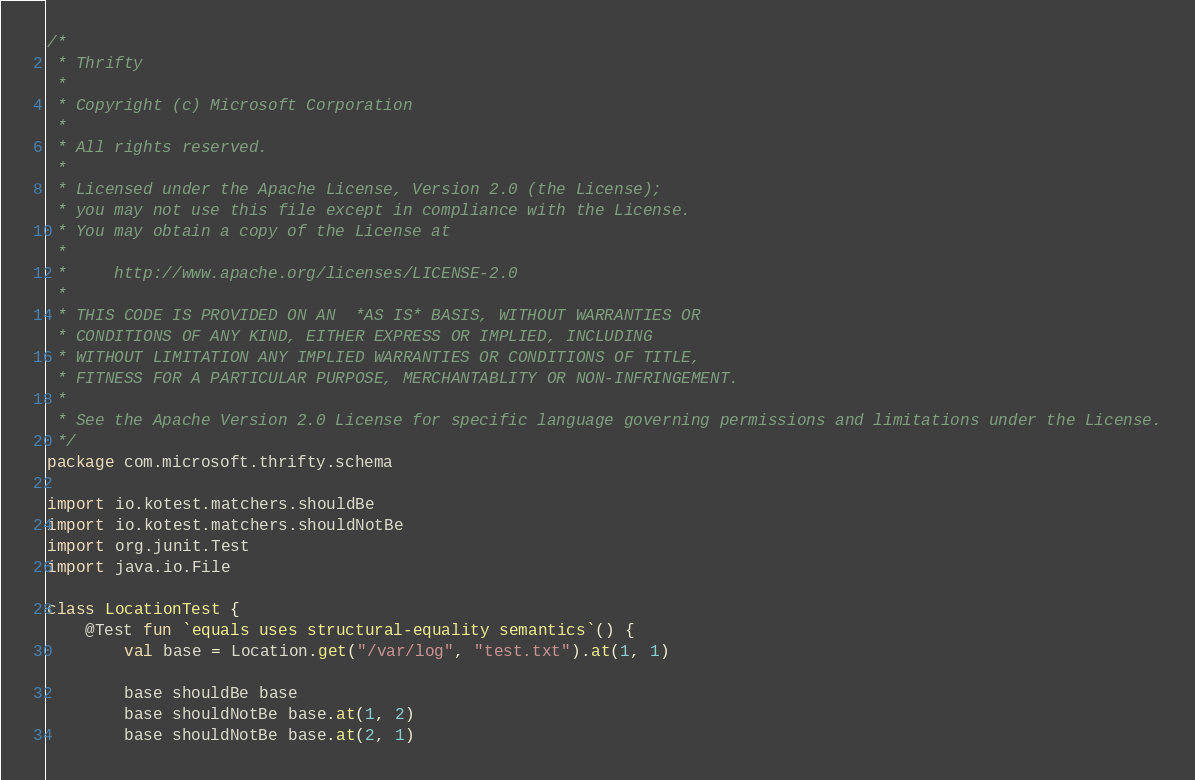<code> <loc_0><loc_0><loc_500><loc_500><_Kotlin_>/*
 * Thrifty
 *
 * Copyright (c) Microsoft Corporation
 *
 * All rights reserved.
 *
 * Licensed under the Apache License, Version 2.0 (the License);
 * you may not use this file except in compliance with the License.
 * You may obtain a copy of the License at
 *
 *     http://www.apache.org/licenses/LICENSE-2.0
 *
 * THIS CODE IS PROVIDED ON AN  *AS IS* BASIS, WITHOUT WARRANTIES OR
 * CONDITIONS OF ANY KIND, EITHER EXPRESS OR IMPLIED, INCLUDING
 * WITHOUT LIMITATION ANY IMPLIED WARRANTIES OR CONDITIONS OF TITLE,
 * FITNESS FOR A PARTICULAR PURPOSE, MERCHANTABLITY OR NON-INFRINGEMENT.
 *
 * See the Apache Version 2.0 License for specific language governing permissions and limitations under the License.
 */
package com.microsoft.thrifty.schema

import io.kotest.matchers.shouldBe
import io.kotest.matchers.shouldNotBe
import org.junit.Test
import java.io.File

class LocationTest {
    @Test fun `equals uses structural-equality semantics`() {
        val base = Location.get("/var/log", "test.txt").at(1, 1)

        base shouldBe base
        base shouldNotBe base.at(1, 2)
        base shouldNotBe base.at(2, 1)</code> 